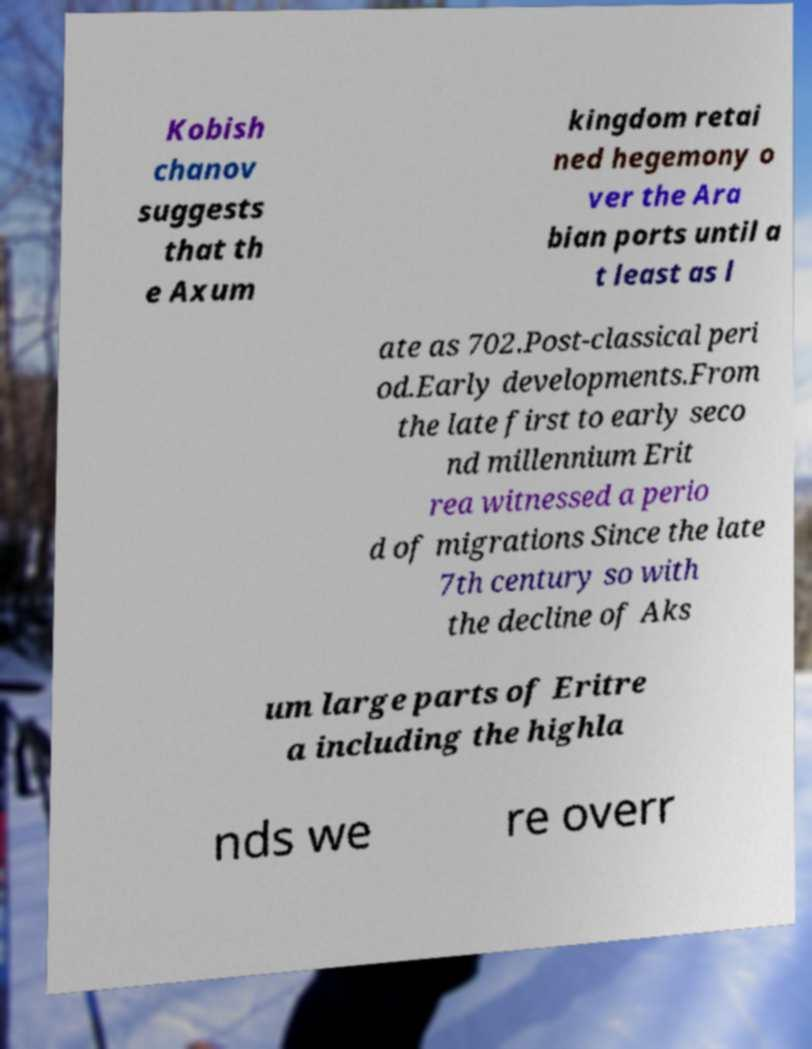Could you extract and type out the text from this image? Kobish chanov suggests that th e Axum kingdom retai ned hegemony o ver the Ara bian ports until a t least as l ate as 702.Post-classical peri od.Early developments.From the late first to early seco nd millennium Erit rea witnessed a perio d of migrations Since the late 7th century so with the decline of Aks um large parts of Eritre a including the highla nds we re overr 